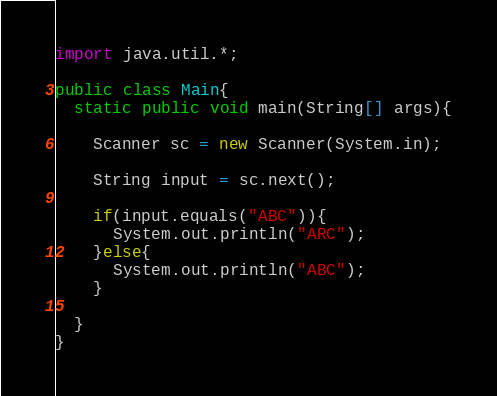<code> <loc_0><loc_0><loc_500><loc_500><_Java_>import java.util.*;

public class Main{
  static public void main(String[] args){
    
    Scanner sc = new Scanner(System.in);
    
    String input = sc.next();
    
    if(input.equals("ABC")){
      System.out.println("ARC");
    }else{
      System.out.println("ABC");
    }
    
  }
}</code> 